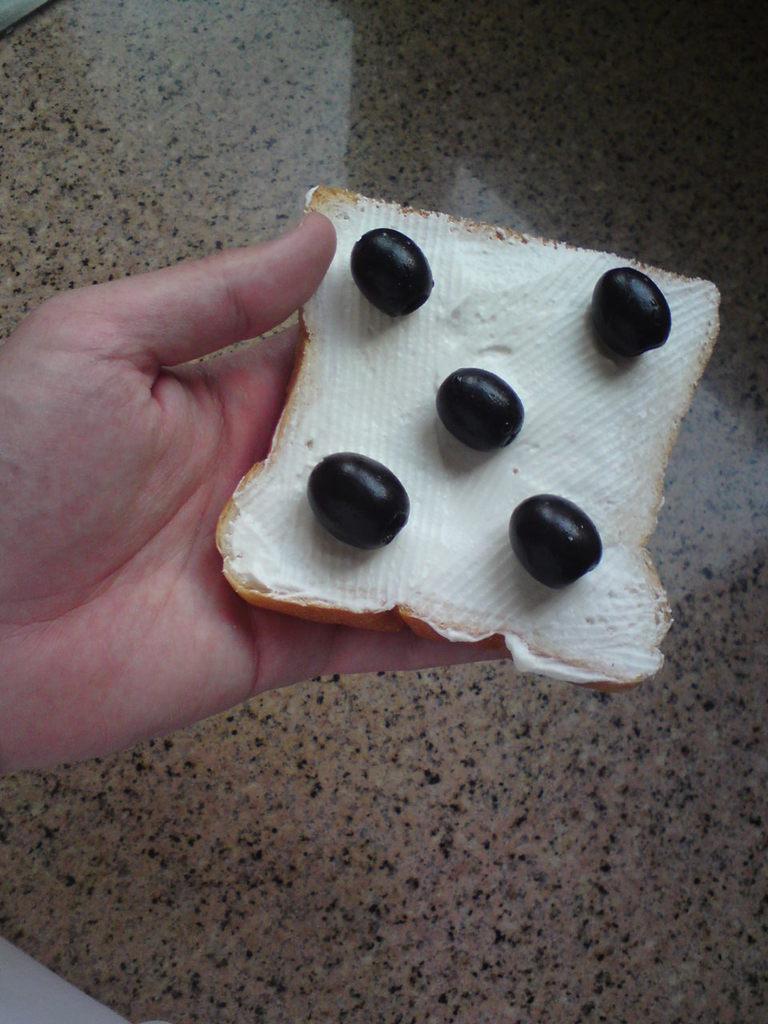Describe this image in one or two sentences. In the image a person is holding a bread slice and there is some cream applied on the bread and few berries were kept upon the cream, in the background there is a floor. 